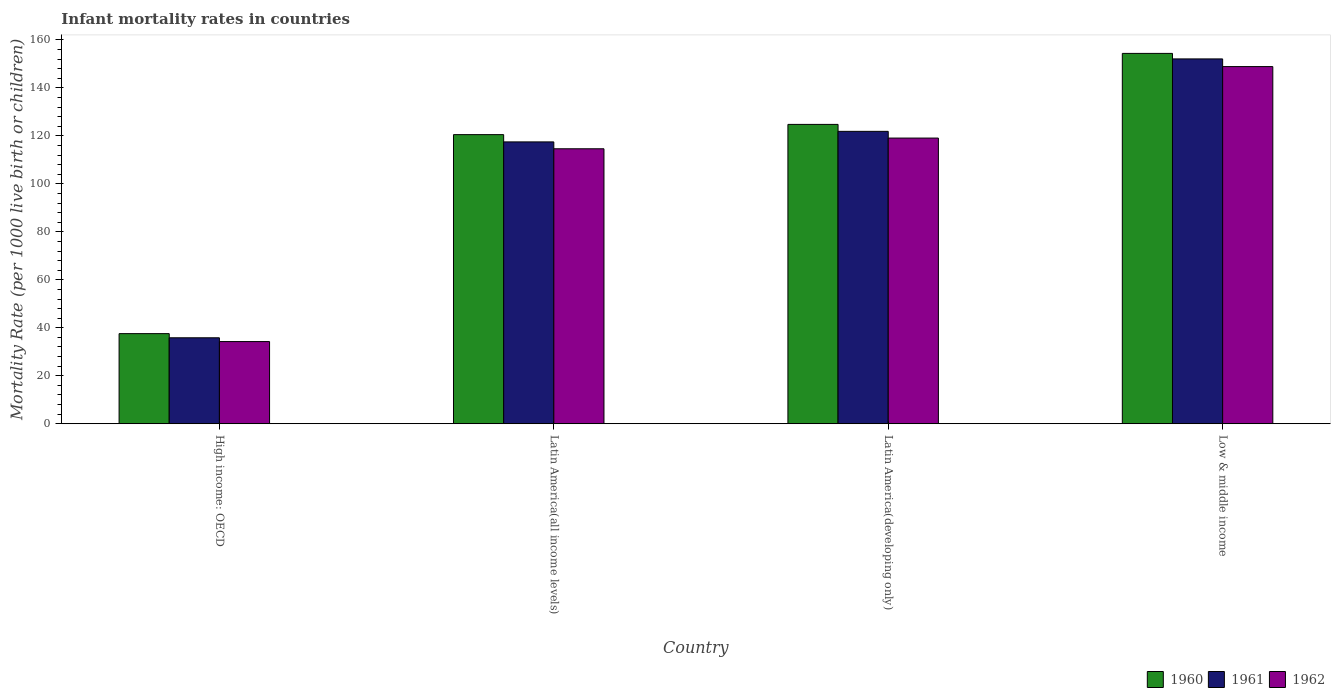How many groups of bars are there?
Give a very brief answer. 4. Are the number of bars per tick equal to the number of legend labels?
Provide a short and direct response. Yes. Are the number of bars on each tick of the X-axis equal?
Offer a terse response. Yes. How many bars are there on the 2nd tick from the left?
Your answer should be compact. 3. What is the label of the 2nd group of bars from the left?
Make the answer very short. Latin America(all income levels). What is the infant mortality rate in 1961 in High income: OECD?
Ensure brevity in your answer.  35.84. Across all countries, what is the maximum infant mortality rate in 1962?
Your answer should be very brief. 148.9. Across all countries, what is the minimum infant mortality rate in 1962?
Offer a very short reply. 34.26. In which country was the infant mortality rate in 1960 maximum?
Make the answer very short. Low & middle income. In which country was the infant mortality rate in 1962 minimum?
Offer a terse response. High income: OECD. What is the total infant mortality rate in 1961 in the graph?
Keep it short and to the point. 427.34. What is the difference between the infant mortality rate in 1960 in High income: OECD and that in Latin America(all income levels)?
Ensure brevity in your answer.  -82.96. What is the difference between the infant mortality rate in 1960 in Latin America(all income levels) and the infant mortality rate in 1961 in Latin America(developing only)?
Offer a very short reply. -1.37. What is the average infant mortality rate in 1962 per country?
Keep it short and to the point. 104.22. What is the difference between the infant mortality rate of/in 1961 and infant mortality rate of/in 1962 in High income: OECD?
Your response must be concise. 1.58. In how many countries, is the infant mortality rate in 1960 greater than 76?
Provide a succinct answer. 3. What is the ratio of the infant mortality rate in 1960 in Latin America(all income levels) to that in Latin America(developing only)?
Offer a very short reply. 0.97. Is the difference between the infant mortality rate in 1961 in Latin America(developing only) and Low & middle income greater than the difference between the infant mortality rate in 1962 in Latin America(developing only) and Low & middle income?
Your answer should be very brief. No. What is the difference between the highest and the second highest infant mortality rate in 1960?
Make the answer very short. -33.87. What is the difference between the highest and the lowest infant mortality rate in 1962?
Make the answer very short. 114.64. Is the sum of the infant mortality rate in 1960 in High income: OECD and Low & middle income greater than the maximum infant mortality rate in 1961 across all countries?
Your answer should be compact. Yes. What does the 2nd bar from the left in Latin America(developing only) represents?
Your answer should be very brief. 1961. Is it the case that in every country, the sum of the infant mortality rate in 1962 and infant mortality rate in 1961 is greater than the infant mortality rate in 1960?
Provide a short and direct response. Yes. Are all the bars in the graph horizontal?
Ensure brevity in your answer.  No. Does the graph contain grids?
Your answer should be very brief. No. What is the title of the graph?
Keep it short and to the point. Infant mortality rates in countries. Does "1999" appear as one of the legend labels in the graph?
Provide a short and direct response. No. What is the label or title of the Y-axis?
Offer a terse response. Mortality Rate (per 1000 live birth or children). What is the Mortality Rate (per 1000 live birth or children) of 1960 in High income: OECD?
Provide a short and direct response. 37.57. What is the Mortality Rate (per 1000 live birth or children) of 1961 in High income: OECD?
Provide a succinct answer. 35.84. What is the Mortality Rate (per 1000 live birth or children) in 1962 in High income: OECD?
Your answer should be compact. 34.26. What is the Mortality Rate (per 1000 live birth or children) in 1960 in Latin America(all income levels)?
Give a very brief answer. 120.53. What is the Mortality Rate (per 1000 live birth or children) of 1961 in Latin America(all income levels)?
Offer a terse response. 117.5. What is the Mortality Rate (per 1000 live birth or children) of 1962 in Latin America(all income levels)?
Your answer should be very brief. 114.64. What is the Mortality Rate (per 1000 live birth or children) of 1960 in Latin America(developing only)?
Your answer should be very brief. 124.8. What is the Mortality Rate (per 1000 live birth or children) in 1961 in Latin America(developing only)?
Your answer should be compact. 121.9. What is the Mortality Rate (per 1000 live birth or children) in 1962 in Latin America(developing only)?
Ensure brevity in your answer.  119.1. What is the Mortality Rate (per 1000 live birth or children) in 1960 in Low & middle income?
Your answer should be very brief. 154.4. What is the Mortality Rate (per 1000 live birth or children) of 1961 in Low & middle income?
Offer a terse response. 152.1. What is the Mortality Rate (per 1000 live birth or children) of 1962 in Low & middle income?
Your response must be concise. 148.9. Across all countries, what is the maximum Mortality Rate (per 1000 live birth or children) in 1960?
Your answer should be compact. 154.4. Across all countries, what is the maximum Mortality Rate (per 1000 live birth or children) in 1961?
Your answer should be compact. 152.1. Across all countries, what is the maximum Mortality Rate (per 1000 live birth or children) of 1962?
Offer a terse response. 148.9. Across all countries, what is the minimum Mortality Rate (per 1000 live birth or children) of 1960?
Your answer should be very brief. 37.57. Across all countries, what is the minimum Mortality Rate (per 1000 live birth or children) of 1961?
Your response must be concise. 35.84. Across all countries, what is the minimum Mortality Rate (per 1000 live birth or children) of 1962?
Offer a terse response. 34.26. What is the total Mortality Rate (per 1000 live birth or children) of 1960 in the graph?
Keep it short and to the point. 437.3. What is the total Mortality Rate (per 1000 live birth or children) of 1961 in the graph?
Ensure brevity in your answer.  427.34. What is the total Mortality Rate (per 1000 live birth or children) of 1962 in the graph?
Your answer should be very brief. 416.89. What is the difference between the Mortality Rate (per 1000 live birth or children) of 1960 in High income: OECD and that in Latin America(all income levels)?
Provide a succinct answer. -82.96. What is the difference between the Mortality Rate (per 1000 live birth or children) in 1961 in High income: OECD and that in Latin America(all income levels)?
Offer a very short reply. -81.67. What is the difference between the Mortality Rate (per 1000 live birth or children) in 1962 in High income: OECD and that in Latin America(all income levels)?
Keep it short and to the point. -80.38. What is the difference between the Mortality Rate (per 1000 live birth or children) in 1960 in High income: OECD and that in Latin America(developing only)?
Give a very brief answer. -87.23. What is the difference between the Mortality Rate (per 1000 live birth or children) in 1961 in High income: OECD and that in Latin America(developing only)?
Make the answer very short. -86.06. What is the difference between the Mortality Rate (per 1000 live birth or children) of 1962 in High income: OECD and that in Latin America(developing only)?
Offer a terse response. -84.84. What is the difference between the Mortality Rate (per 1000 live birth or children) of 1960 in High income: OECD and that in Low & middle income?
Your response must be concise. -116.83. What is the difference between the Mortality Rate (per 1000 live birth or children) of 1961 in High income: OECD and that in Low & middle income?
Keep it short and to the point. -116.26. What is the difference between the Mortality Rate (per 1000 live birth or children) of 1962 in High income: OECD and that in Low & middle income?
Offer a terse response. -114.64. What is the difference between the Mortality Rate (per 1000 live birth or children) of 1960 in Latin America(all income levels) and that in Latin America(developing only)?
Give a very brief answer. -4.27. What is the difference between the Mortality Rate (per 1000 live birth or children) of 1961 in Latin America(all income levels) and that in Latin America(developing only)?
Offer a very short reply. -4.4. What is the difference between the Mortality Rate (per 1000 live birth or children) of 1962 in Latin America(all income levels) and that in Latin America(developing only)?
Offer a terse response. -4.46. What is the difference between the Mortality Rate (per 1000 live birth or children) in 1960 in Latin America(all income levels) and that in Low & middle income?
Your answer should be compact. -33.87. What is the difference between the Mortality Rate (per 1000 live birth or children) in 1961 in Latin America(all income levels) and that in Low & middle income?
Make the answer very short. -34.6. What is the difference between the Mortality Rate (per 1000 live birth or children) in 1962 in Latin America(all income levels) and that in Low & middle income?
Make the answer very short. -34.26. What is the difference between the Mortality Rate (per 1000 live birth or children) of 1960 in Latin America(developing only) and that in Low & middle income?
Keep it short and to the point. -29.6. What is the difference between the Mortality Rate (per 1000 live birth or children) of 1961 in Latin America(developing only) and that in Low & middle income?
Keep it short and to the point. -30.2. What is the difference between the Mortality Rate (per 1000 live birth or children) in 1962 in Latin America(developing only) and that in Low & middle income?
Your answer should be compact. -29.8. What is the difference between the Mortality Rate (per 1000 live birth or children) in 1960 in High income: OECD and the Mortality Rate (per 1000 live birth or children) in 1961 in Latin America(all income levels)?
Ensure brevity in your answer.  -79.93. What is the difference between the Mortality Rate (per 1000 live birth or children) of 1960 in High income: OECD and the Mortality Rate (per 1000 live birth or children) of 1962 in Latin America(all income levels)?
Offer a terse response. -77.07. What is the difference between the Mortality Rate (per 1000 live birth or children) in 1961 in High income: OECD and the Mortality Rate (per 1000 live birth or children) in 1962 in Latin America(all income levels)?
Make the answer very short. -78.8. What is the difference between the Mortality Rate (per 1000 live birth or children) in 1960 in High income: OECD and the Mortality Rate (per 1000 live birth or children) in 1961 in Latin America(developing only)?
Ensure brevity in your answer.  -84.33. What is the difference between the Mortality Rate (per 1000 live birth or children) of 1960 in High income: OECD and the Mortality Rate (per 1000 live birth or children) of 1962 in Latin America(developing only)?
Give a very brief answer. -81.53. What is the difference between the Mortality Rate (per 1000 live birth or children) in 1961 in High income: OECD and the Mortality Rate (per 1000 live birth or children) in 1962 in Latin America(developing only)?
Offer a very short reply. -83.26. What is the difference between the Mortality Rate (per 1000 live birth or children) of 1960 in High income: OECD and the Mortality Rate (per 1000 live birth or children) of 1961 in Low & middle income?
Offer a very short reply. -114.53. What is the difference between the Mortality Rate (per 1000 live birth or children) in 1960 in High income: OECD and the Mortality Rate (per 1000 live birth or children) in 1962 in Low & middle income?
Your answer should be compact. -111.33. What is the difference between the Mortality Rate (per 1000 live birth or children) in 1961 in High income: OECD and the Mortality Rate (per 1000 live birth or children) in 1962 in Low & middle income?
Provide a succinct answer. -113.06. What is the difference between the Mortality Rate (per 1000 live birth or children) of 1960 in Latin America(all income levels) and the Mortality Rate (per 1000 live birth or children) of 1961 in Latin America(developing only)?
Provide a short and direct response. -1.37. What is the difference between the Mortality Rate (per 1000 live birth or children) of 1960 in Latin America(all income levels) and the Mortality Rate (per 1000 live birth or children) of 1962 in Latin America(developing only)?
Offer a terse response. 1.43. What is the difference between the Mortality Rate (per 1000 live birth or children) in 1961 in Latin America(all income levels) and the Mortality Rate (per 1000 live birth or children) in 1962 in Latin America(developing only)?
Make the answer very short. -1.6. What is the difference between the Mortality Rate (per 1000 live birth or children) in 1960 in Latin America(all income levels) and the Mortality Rate (per 1000 live birth or children) in 1961 in Low & middle income?
Make the answer very short. -31.57. What is the difference between the Mortality Rate (per 1000 live birth or children) in 1960 in Latin America(all income levels) and the Mortality Rate (per 1000 live birth or children) in 1962 in Low & middle income?
Your answer should be very brief. -28.37. What is the difference between the Mortality Rate (per 1000 live birth or children) of 1961 in Latin America(all income levels) and the Mortality Rate (per 1000 live birth or children) of 1962 in Low & middle income?
Ensure brevity in your answer.  -31.4. What is the difference between the Mortality Rate (per 1000 live birth or children) in 1960 in Latin America(developing only) and the Mortality Rate (per 1000 live birth or children) in 1961 in Low & middle income?
Your response must be concise. -27.3. What is the difference between the Mortality Rate (per 1000 live birth or children) of 1960 in Latin America(developing only) and the Mortality Rate (per 1000 live birth or children) of 1962 in Low & middle income?
Keep it short and to the point. -24.1. What is the difference between the Mortality Rate (per 1000 live birth or children) of 1961 in Latin America(developing only) and the Mortality Rate (per 1000 live birth or children) of 1962 in Low & middle income?
Offer a very short reply. -27. What is the average Mortality Rate (per 1000 live birth or children) in 1960 per country?
Make the answer very short. 109.33. What is the average Mortality Rate (per 1000 live birth or children) in 1961 per country?
Your answer should be very brief. 106.83. What is the average Mortality Rate (per 1000 live birth or children) of 1962 per country?
Provide a succinct answer. 104.22. What is the difference between the Mortality Rate (per 1000 live birth or children) of 1960 and Mortality Rate (per 1000 live birth or children) of 1961 in High income: OECD?
Ensure brevity in your answer.  1.73. What is the difference between the Mortality Rate (per 1000 live birth or children) of 1960 and Mortality Rate (per 1000 live birth or children) of 1962 in High income: OECD?
Give a very brief answer. 3.31. What is the difference between the Mortality Rate (per 1000 live birth or children) in 1961 and Mortality Rate (per 1000 live birth or children) in 1962 in High income: OECD?
Give a very brief answer. 1.58. What is the difference between the Mortality Rate (per 1000 live birth or children) of 1960 and Mortality Rate (per 1000 live birth or children) of 1961 in Latin America(all income levels)?
Your response must be concise. 3.03. What is the difference between the Mortality Rate (per 1000 live birth or children) in 1960 and Mortality Rate (per 1000 live birth or children) in 1962 in Latin America(all income levels)?
Ensure brevity in your answer.  5.9. What is the difference between the Mortality Rate (per 1000 live birth or children) of 1961 and Mortality Rate (per 1000 live birth or children) of 1962 in Latin America(all income levels)?
Provide a short and direct response. 2.87. What is the difference between the Mortality Rate (per 1000 live birth or children) of 1960 and Mortality Rate (per 1000 live birth or children) of 1962 in Low & middle income?
Your answer should be very brief. 5.5. What is the difference between the Mortality Rate (per 1000 live birth or children) of 1961 and Mortality Rate (per 1000 live birth or children) of 1962 in Low & middle income?
Your answer should be compact. 3.2. What is the ratio of the Mortality Rate (per 1000 live birth or children) in 1960 in High income: OECD to that in Latin America(all income levels)?
Provide a short and direct response. 0.31. What is the ratio of the Mortality Rate (per 1000 live birth or children) of 1961 in High income: OECD to that in Latin America(all income levels)?
Your answer should be compact. 0.3. What is the ratio of the Mortality Rate (per 1000 live birth or children) of 1962 in High income: OECD to that in Latin America(all income levels)?
Your answer should be compact. 0.3. What is the ratio of the Mortality Rate (per 1000 live birth or children) of 1960 in High income: OECD to that in Latin America(developing only)?
Ensure brevity in your answer.  0.3. What is the ratio of the Mortality Rate (per 1000 live birth or children) in 1961 in High income: OECD to that in Latin America(developing only)?
Offer a terse response. 0.29. What is the ratio of the Mortality Rate (per 1000 live birth or children) of 1962 in High income: OECD to that in Latin America(developing only)?
Your response must be concise. 0.29. What is the ratio of the Mortality Rate (per 1000 live birth or children) in 1960 in High income: OECD to that in Low & middle income?
Offer a terse response. 0.24. What is the ratio of the Mortality Rate (per 1000 live birth or children) of 1961 in High income: OECD to that in Low & middle income?
Make the answer very short. 0.24. What is the ratio of the Mortality Rate (per 1000 live birth or children) of 1962 in High income: OECD to that in Low & middle income?
Offer a terse response. 0.23. What is the ratio of the Mortality Rate (per 1000 live birth or children) of 1960 in Latin America(all income levels) to that in Latin America(developing only)?
Your answer should be very brief. 0.97. What is the ratio of the Mortality Rate (per 1000 live birth or children) in 1961 in Latin America(all income levels) to that in Latin America(developing only)?
Provide a short and direct response. 0.96. What is the ratio of the Mortality Rate (per 1000 live birth or children) of 1962 in Latin America(all income levels) to that in Latin America(developing only)?
Ensure brevity in your answer.  0.96. What is the ratio of the Mortality Rate (per 1000 live birth or children) of 1960 in Latin America(all income levels) to that in Low & middle income?
Offer a very short reply. 0.78. What is the ratio of the Mortality Rate (per 1000 live birth or children) of 1961 in Latin America(all income levels) to that in Low & middle income?
Provide a short and direct response. 0.77. What is the ratio of the Mortality Rate (per 1000 live birth or children) in 1962 in Latin America(all income levels) to that in Low & middle income?
Your answer should be compact. 0.77. What is the ratio of the Mortality Rate (per 1000 live birth or children) of 1960 in Latin America(developing only) to that in Low & middle income?
Ensure brevity in your answer.  0.81. What is the ratio of the Mortality Rate (per 1000 live birth or children) in 1961 in Latin America(developing only) to that in Low & middle income?
Provide a succinct answer. 0.8. What is the ratio of the Mortality Rate (per 1000 live birth or children) of 1962 in Latin America(developing only) to that in Low & middle income?
Provide a short and direct response. 0.8. What is the difference between the highest and the second highest Mortality Rate (per 1000 live birth or children) in 1960?
Give a very brief answer. 29.6. What is the difference between the highest and the second highest Mortality Rate (per 1000 live birth or children) in 1961?
Offer a very short reply. 30.2. What is the difference between the highest and the second highest Mortality Rate (per 1000 live birth or children) in 1962?
Ensure brevity in your answer.  29.8. What is the difference between the highest and the lowest Mortality Rate (per 1000 live birth or children) of 1960?
Provide a succinct answer. 116.83. What is the difference between the highest and the lowest Mortality Rate (per 1000 live birth or children) of 1961?
Provide a succinct answer. 116.26. What is the difference between the highest and the lowest Mortality Rate (per 1000 live birth or children) in 1962?
Ensure brevity in your answer.  114.64. 